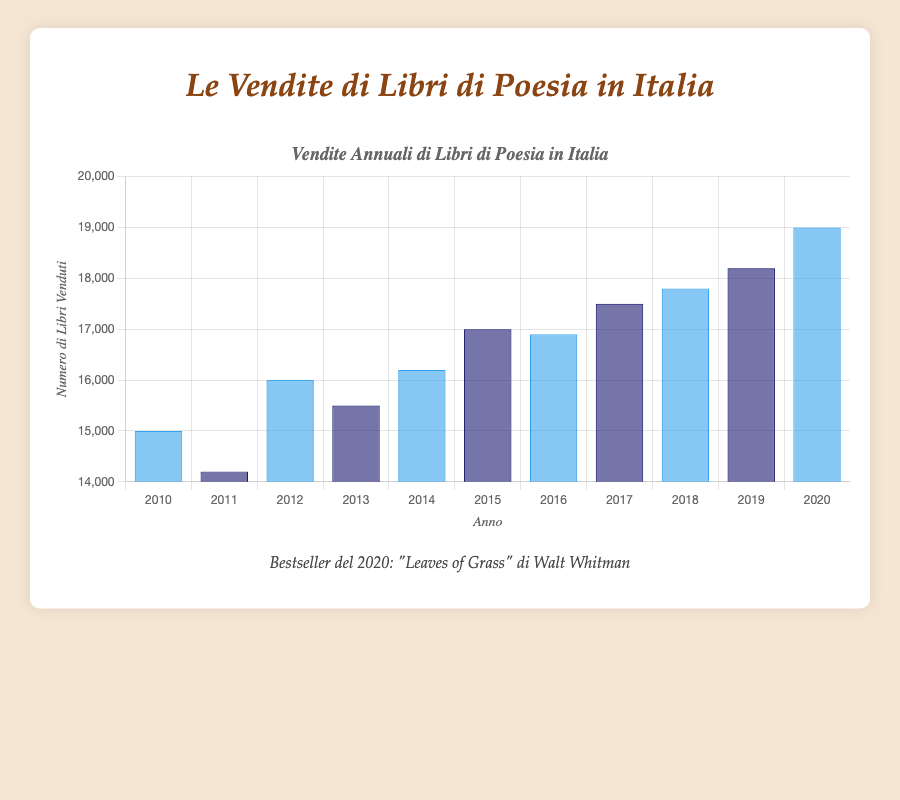Which year had the highest sales of poetry books? By looking at the bar chart, identify the tallest bar. The tallest bar corresponds to the year 2020 with sales of 19,000 books.
Answer: 2020 What was the bestseller in the year with the lowest sales? Locate the lowest bar, which represents the year with the lowest sales. The year 2011 had the lowest sales (14,200 books), and the bestseller for that year was "Canti by Giacomo Leopardi."
Answer: Canti by Giacomo Leopardi How much did the sales of poetry books increase from 2010 to 2020? Subtract the sales in 2010 from the sales in 2020. Sales in 2010 were 15,000, and sales in 2020 were 19,000. The increase is 19,000 - 15,000 = 4,000 books.
Answer: 4,000 During which years were the sales of poetry books between 16,000 and 17,000? Identify the bars with heights representing sales between 16,000 and 17,000. These years are 2012 (16,000 books), 2014 (16,200 books), 2015 (17,000 books), and 2016 (16,900 books).
Answer: 2012, 2014, 2015, 2016 Which year had higher sales, 2015 or 2016, and by how much? Compare the heights of the bars for 2015 and 2016. Sales in 2015 were 17,000 books, and in 2016 were 16,900 books. 17,000 - 16,900 = 100 books more in 2015.
Answer: 2015, by 100 books What is the average yearly sales of poetry books from 2017 to 2020? Sum the sales from 2017 to 2020 and divide by the number of years. (17,500 + 17,800 + 18,200 + 19,000) / 4 = 72,500 / 4 = 18,125 books per year.
Answer: 18,125 Identify the years when the bars are colored dark blue. The dark blue bars represent the years 2011, 2013, 2015, 2017, and 2019.
Answer: 2011, 2013, 2015, 2017, 2019 